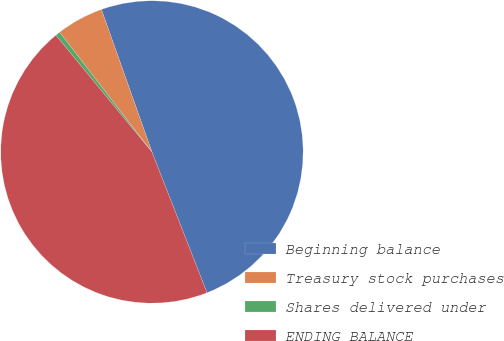Convert chart. <chart><loc_0><loc_0><loc_500><loc_500><pie_chart><fcel>Beginning balance<fcel>Treasury stock purchases<fcel>Shares delivered under<fcel>ENDING BALANCE<nl><fcel>49.49%<fcel>5.03%<fcel>0.51%<fcel>44.97%<nl></chart> 